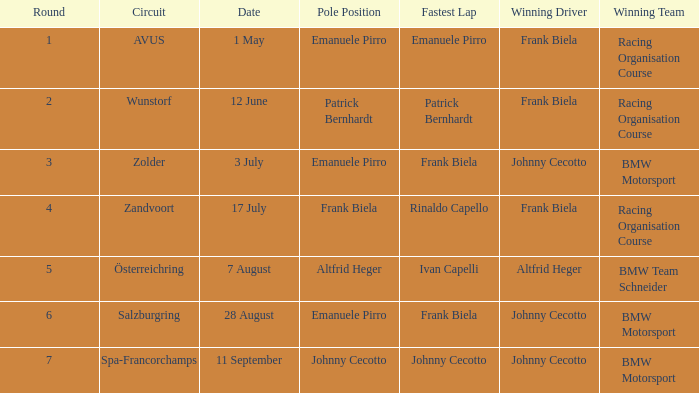Who was the winning team on the circuit Zolder? BMW Motorsport. 